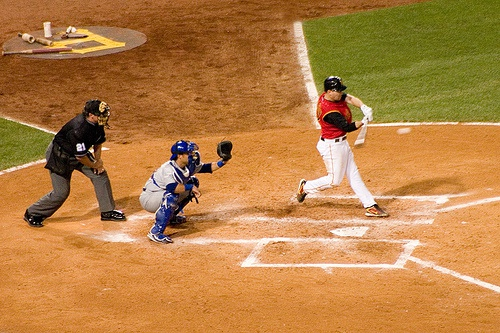Describe the objects in this image and their specific colors. I can see people in red, black, gray, and maroon tones, people in red, white, black, tan, and maroon tones, people in red, black, lightgray, navy, and tan tones, baseball bat in red, brown, maroon, and tan tones, and baseball glove in red, black, gray, and maroon tones in this image. 